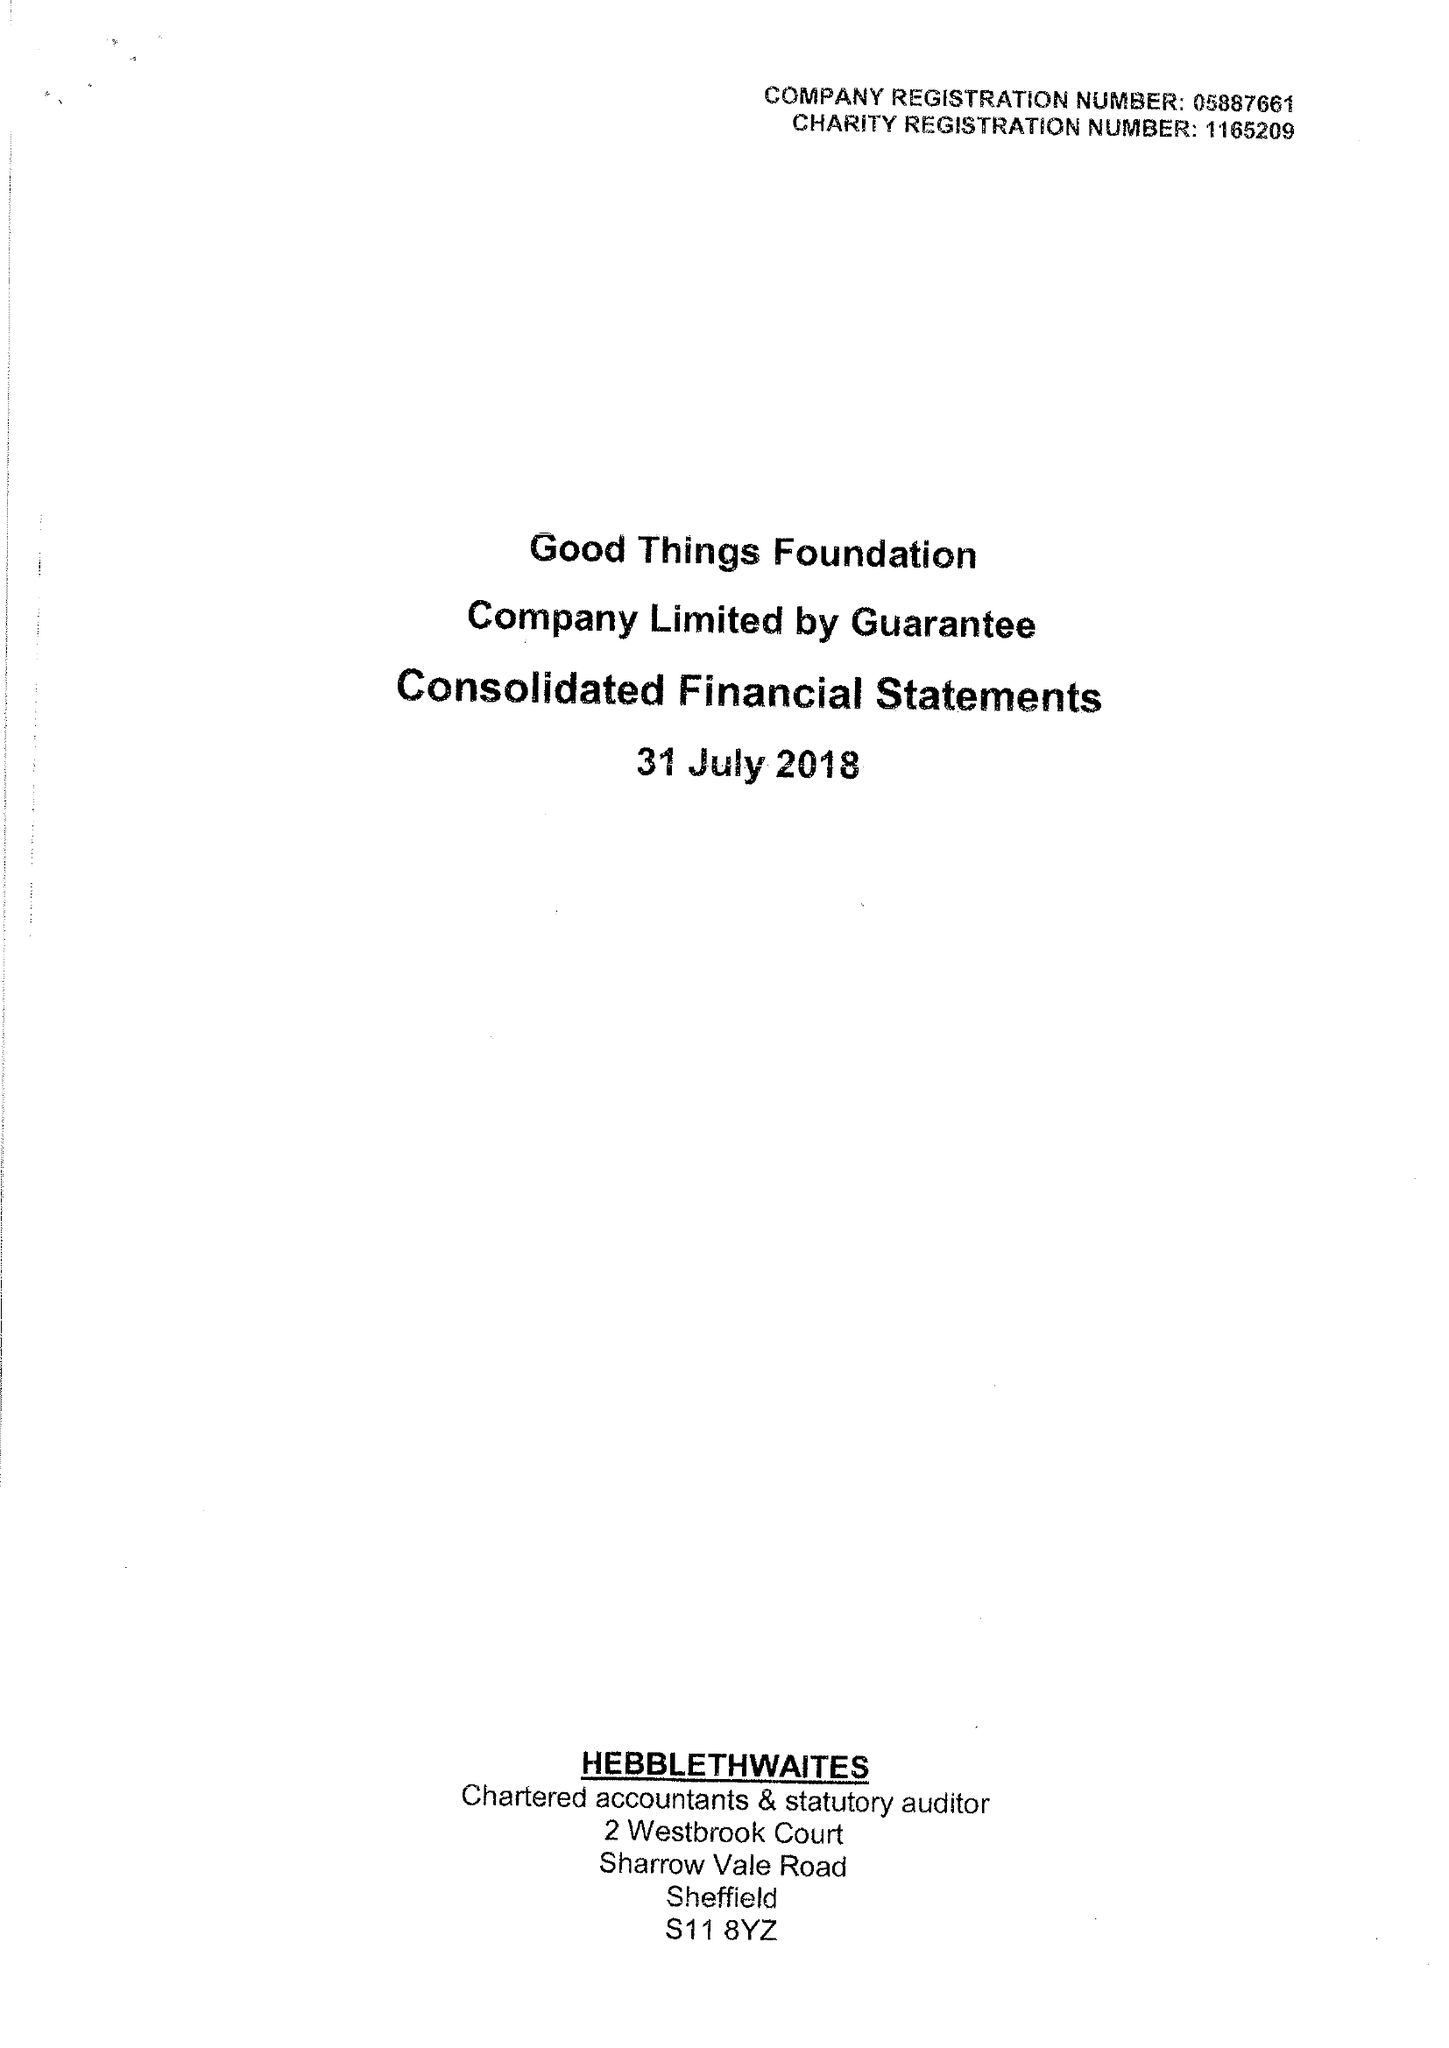What is the value for the spending_annually_in_british_pounds?
Answer the question using a single word or phrase. 9760868.00 